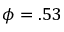<formula> <loc_0><loc_0><loc_500><loc_500>\phi = . 5 3</formula> 